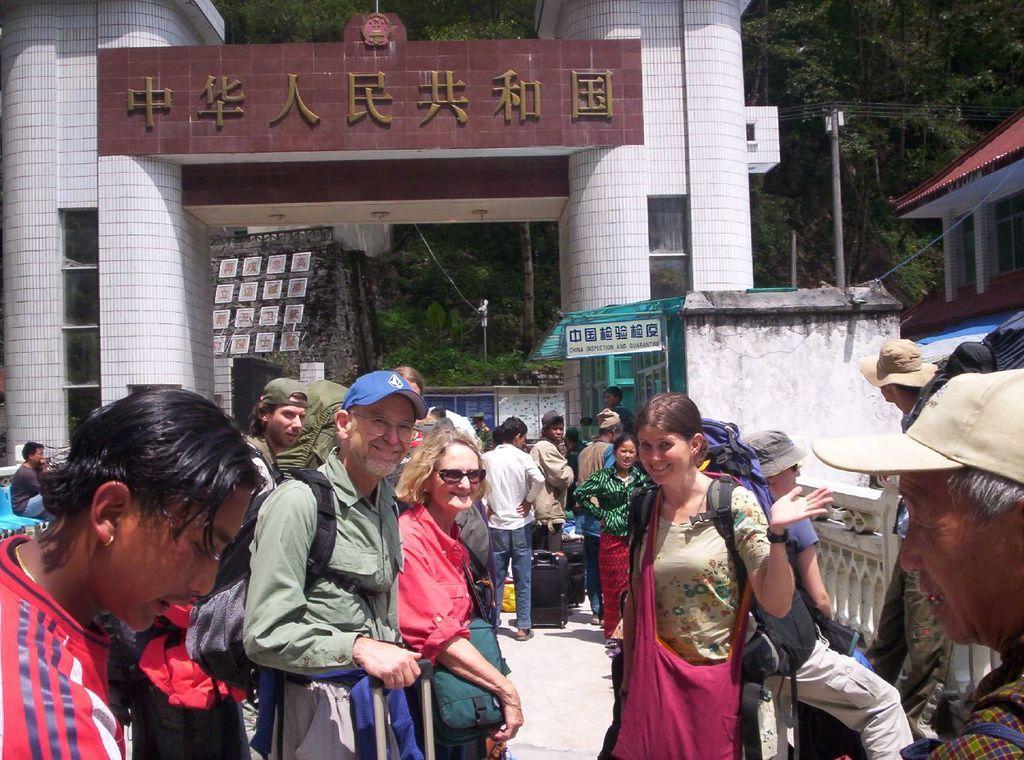In one or two sentences, can you explain what this image depicts? In this picture we can observe some people standing. Three of them were smiling. There are men and women in this picture. In the background there is a building. On the right side there is a pole. We can observe some trees. 